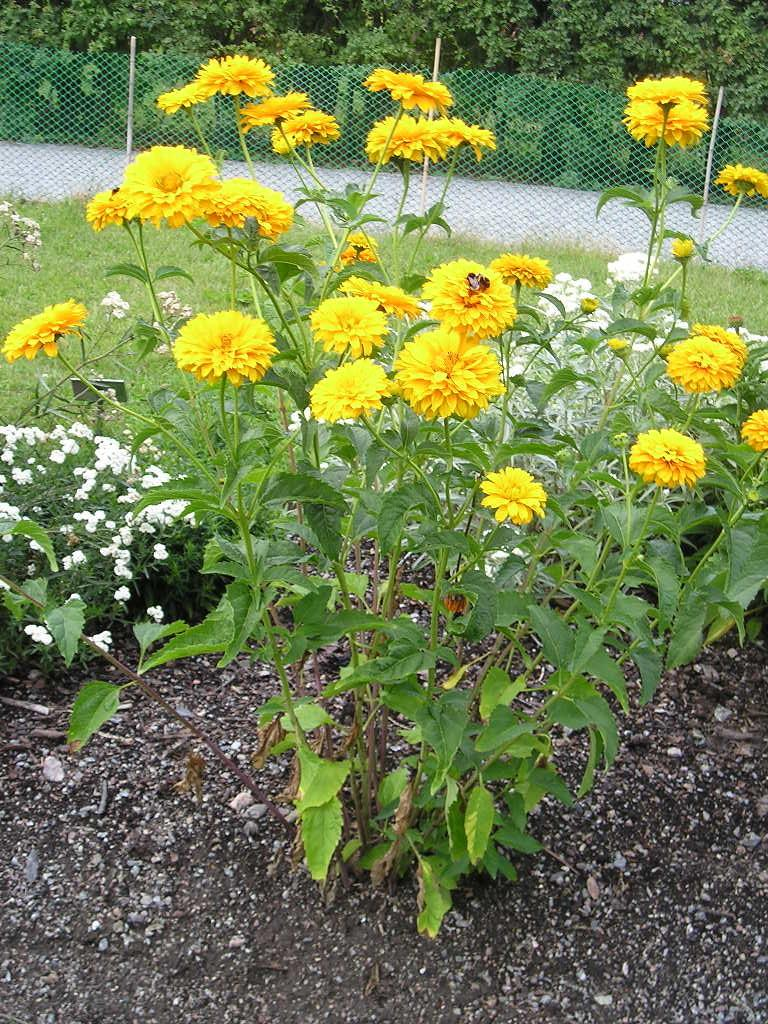What type of vegetation is in the middle of the image? There are trees with flowers in the middle of the image. What can be seen in the background of the image? There are grills and a group of trees in the background of the image. What type of surface is visible at the bottom of the image? There is sand visible at the bottom of the image. What type of band is performing in the image? There is no band present in the image. What actions are the trees with flowers performing in the image? Trees with flowers are not capable of performing actions, as they are inanimate objects. 